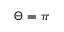Convert formula to latex. <formula><loc_0><loc_0><loc_500><loc_500>\Theta = \pi</formula> 